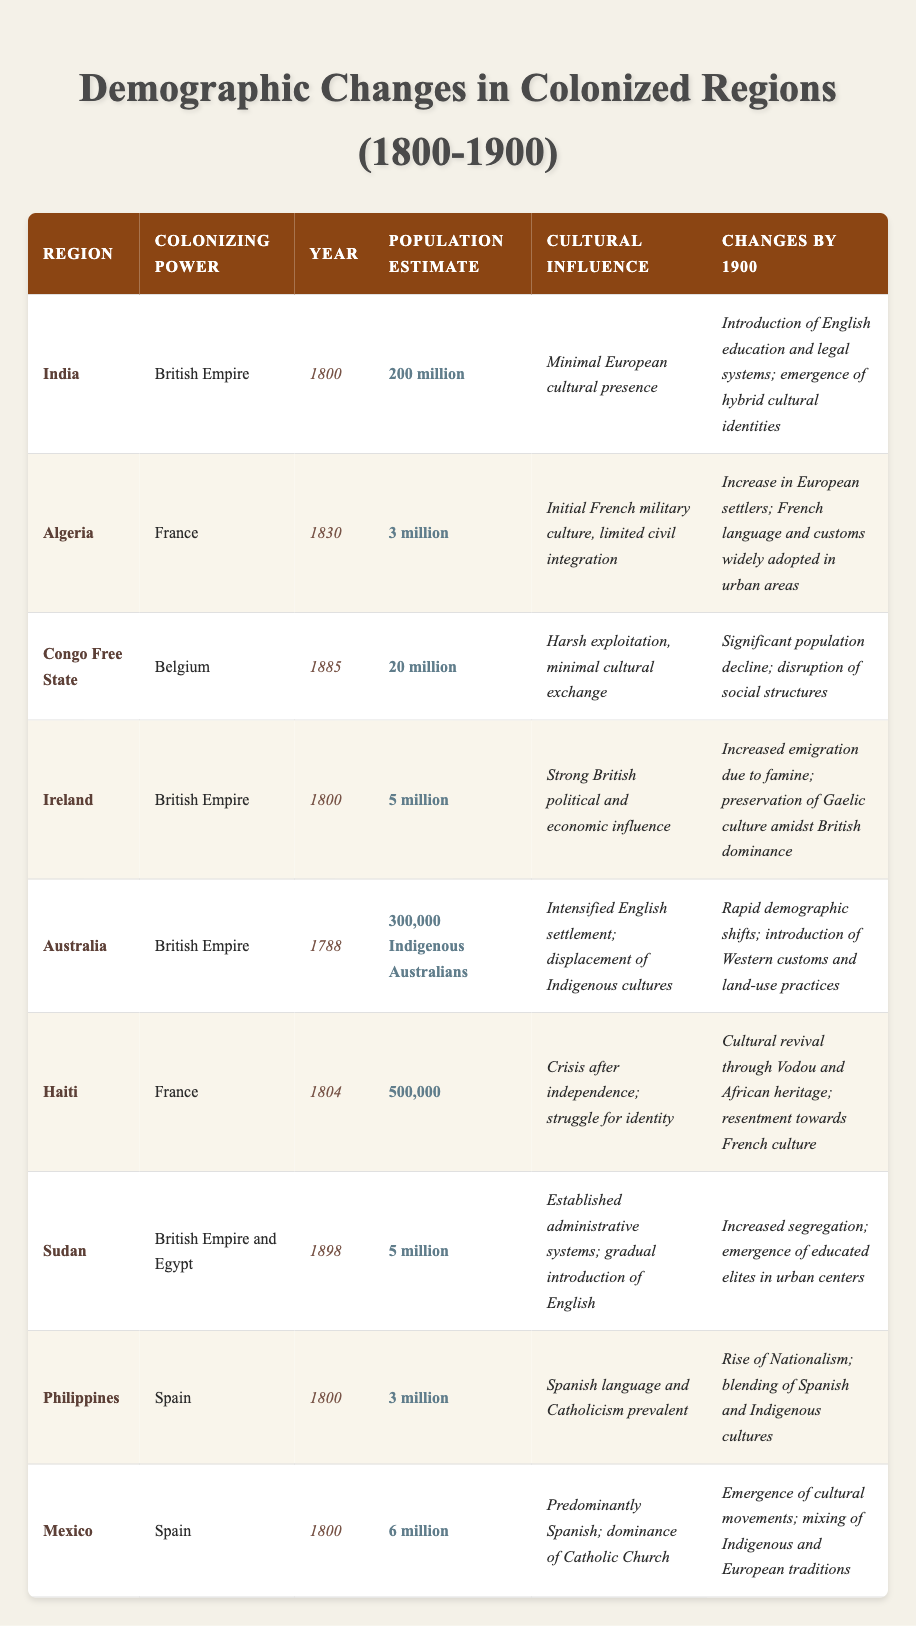What was the population estimate of India in 1800? According to the table, the population estimate for India in 1800 is noted as 200 million.
Answer: 200 million Which colonizing power was present in Algeria in 1830? The table indicates that the colonizing power in Algeria in 1830 was the French Empire.
Answer: France What cultural influence was observed in the Congo Free State by 1900? The table states that by 1900, the cultural influence in the Congo Free State involved significant population decline and disruption of social structures due to harsh exploitation.
Answer: Significant population decline and disruption of social structures How many Indigenous Australians were estimated to be in Australia in 1788? The table shows that in 1788, the estimated population of Indigenous Australians in Australia was 300,000.
Answer: 300,000 What changes occurred in the population of Haiti by 1900? The table notes that by 1900, Haiti experienced a cultural revival through Vodou and African heritage, along with resentment towards French culture.
Answer: Cultural revival and resentment towards French culture Did Ireland experience an increase or decrease in population by 1900? The table highlights that by 1900, Ireland saw increased emigration due to famine, indicating a decrease in population.
Answer: Decrease Which region experienced an introduction of English education and legal systems by 1900? As per the table, India experienced the introduction of English education and legal systems by 1900.
Answer: India What was the cultural influence in Mexico by 1900? The table indicates that in Mexico, by 1900, there was an emergence of cultural movements and mixing of Indigenous and European traditions.
Answer: Emergence of cultural movements and mixing of traditions Which regions had a colonizing power of the British Empire? The table reveals that India, Ireland, and Sudan had the British Empire as their colonizing power.
Answer: India, Ireland, and Sudan What were the changes in the Philippines by 1900 regarding cultural identity? The table describes that by 1900, the Philippines saw a rise of nationalism and a blending of Spanish and Indigenous cultures.
Answer: Rise of nationalism and blending of cultures How did the population of the Congo Free State change from its initial estimate? The table notes that the Congo Free State had an initial population estimate of 20 million, but by 1900, there was a significant population decline.
Answer: Significant population decline Did the introduction of Western customs and land-use practices lead to preservation or displacement of Indigenous cultures in Australia by 1900? The table states that the introduction of Western customs and land-use practices led to the displacement of Indigenous cultures in Australia by 1900.
Answer: Displacement of Indigenous cultures What was the common religious influence across Mexico and the Philippines? According to the table, both Mexico and the Philippines had the dominance of Catholicism as a cultural influence.
Answer: Dominance of Catholicism Which region experienced increased segregation by 1900? The table indicates that Sudan experienced increased segregation by 1900.
Answer: Sudan What was the population estimate of Algeria in 1830? The table shows that the population estimate of Algeria in 1830 was 3 million.
Answer: 3 million What were the cultural influences observed in India in 1800 and Haiti by 1900, and how do they contrast? The table notes that in 1800, India had minimal European cultural presence, while by 1900, Haiti experienced a cultural revival through Vodou and African heritage; India saw the introduction of Western education. This contrast shows a transition from minimal influence in India to a significant revival in Haiti.
Answer: Minimal European influence in India; cultural revival in Haiti 